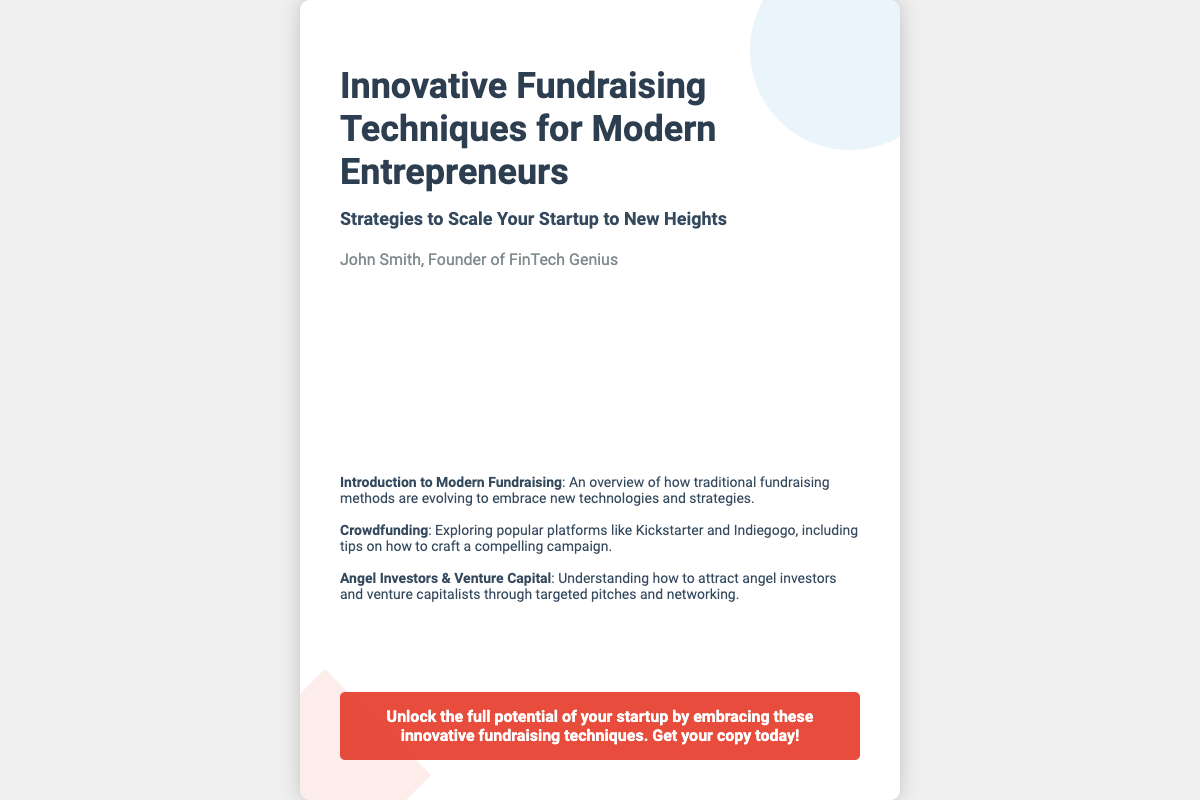What is the title of the book? The title is prominently displayed at the top of the cover, showcasing the main theme.
Answer: Innovative Fundraising Techniques for Modern Entrepreneurs Who is the author of the book? The author’s name is mentioned below the subtitle, identifying the individual behind the content.
Answer: John Smith What is the subtitle of the book? The subtitle provides additional context about what the book will cover, located right under the title.
Answer: Strategies to Scale Your Startup to New Heights What type of fundraising method is discussed first in the sections? The sections list topics covered in the book, starting with an overview of modern fundraising.
Answer: Introduction to Modern Fundraising How many icons are displayed in the icons container? The icons container visually represents various financial concepts and techniques, possessing a set number of icons.
Answer: Six What color is used for the call-to-action button? The call-to-action stands out in color, designed to attract attention for additional promises.
Answer: Red What is one platform mentioned for crowdfunding? The document references specific platforms to illustrate crowdfunding opportunities available to entrepreneurs.
Answer: Kickstarter What does the icon with the dollar sign represent? Each icon has a thematic representation, and the dollar sign is commonly associated with financial discussions.
Answer: Money What is the primary background color of the book cover? The background color plays a crucial role in book design, contributing to its aesthetic appeal.
Answer: White 